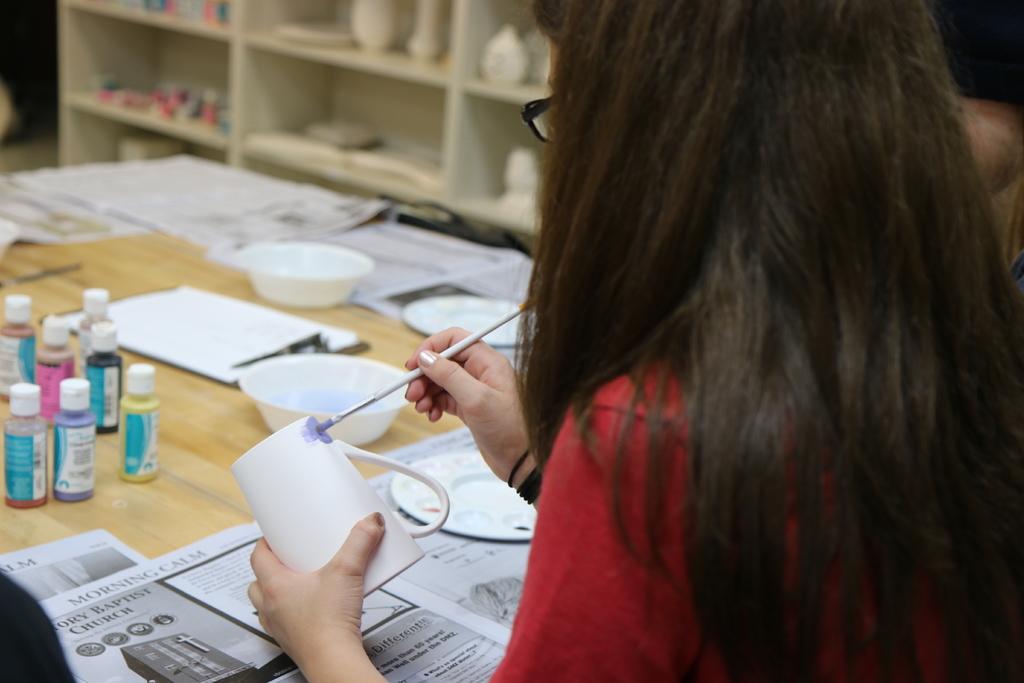Could you give a brief overview of what you see in this image? In this image in the front there is a woman painting a cup. In the center there are bottles on the table, there are bowls, plates and there are papers. In the background there are shelves and in the shelfs there are objects which are white in colour and pink in colour. 